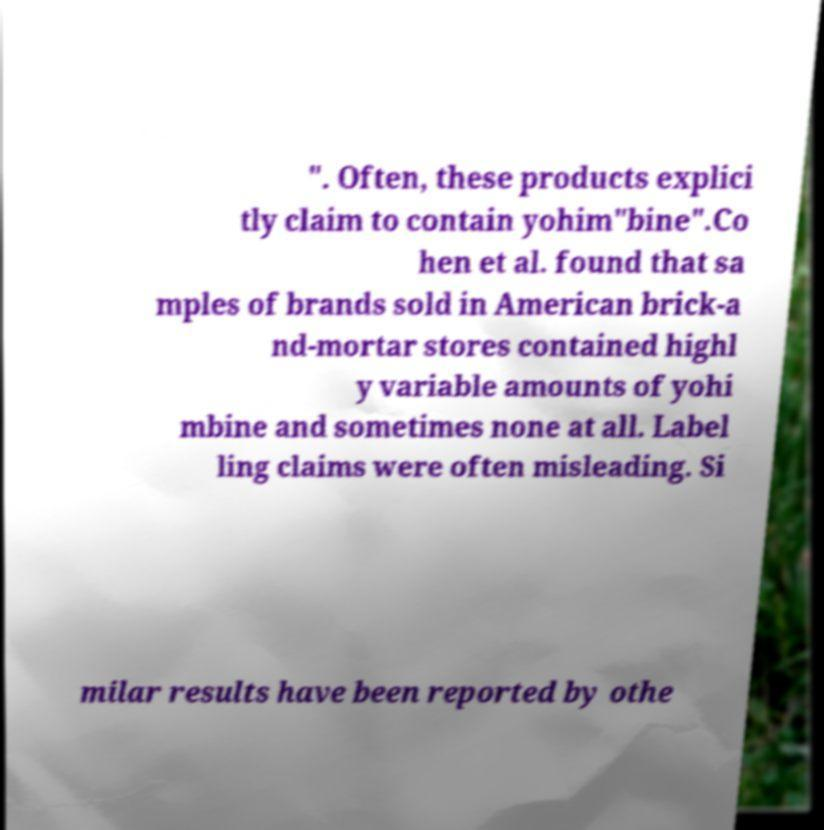There's text embedded in this image that I need extracted. Can you transcribe it verbatim? ". Often, these products explici tly claim to contain yohim"bine".Co hen et al. found that sa mples of brands sold in American brick-a nd-mortar stores contained highl y variable amounts of yohi mbine and sometimes none at all. Label ling claims were often misleading. Si milar results have been reported by othe 